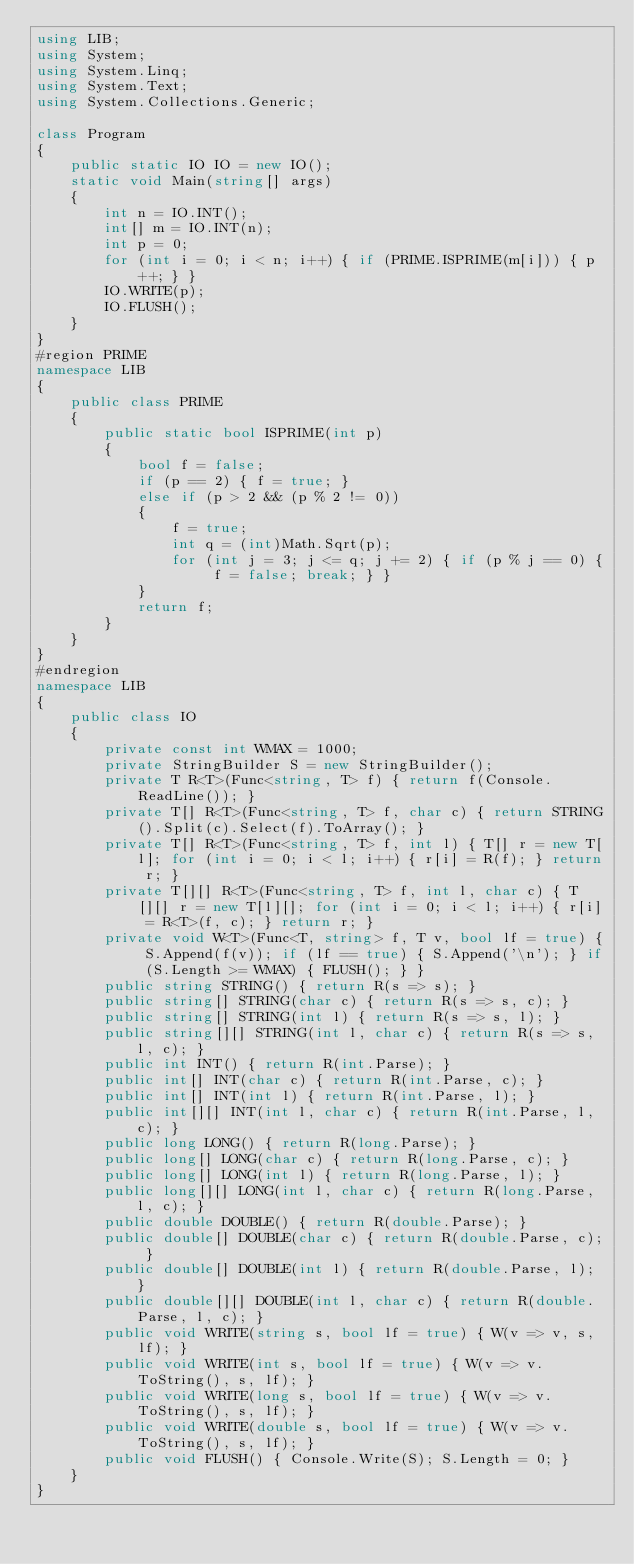<code> <loc_0><loc_0><loc_500><loc_500><_C#_>using LIB;
using System;
using System.Linq;
using System.Text;
using System.Collections.Generic;

class Program
{
    public static IO IO = new IO();
    static void Main(string[] args)
    {
        int n = IO.INT();
        int[] m = IO.INT(n);
        int p = 0;
        for (int i = 0; i < n; i++) { if (PRIME.ISPRIME(m[i])) { p++; } }
        IO.WRITE(p);
        IO.FLUSH();
    }
}
#region PRIME
namespace LIB
{
    public class PRIME
    {
        public static bool ISPRIME(int p)
        {
            bool f = false;
            if (p == 2) { f = true; }
            else if (p > 2 && (p % 2 != 0))
            {
                f = true;
                int q = (int)Math.Sqrt(p);
                for (int j = 3; j <= q; j += 2) { if (p % j == 0) { f = false; break; } }
            }
            return f;
        }
    }
}
#endregion
namespace LIB
{
    public class IO
    {
        private const int WMAX = 1000;
        private StringBuilder S = new StringBuilder();
        private T R<T>(Func<string, T> f) { return f(Console.ReadLine()); }
        private T[] R<T>(Func<string, T> f, char c) { return STRING().Split(c).Select(f).ToArray(); }
        private T[] R<T>(Func<string, T> f, int l) { T[] r = new T[l]; for (int i = 0; i < l; i++) { r[i] = R(f); } return r; }
        private T[][] R<T>(Func<string, T> f, int l, char c) { T[][] r = new T[l][]; for (int i = 0; i < l; i++) { r[i] = R<T>(f, c); } return r; }
        private void W<T>(Func<T, string> f, T v, bool lf = true) { S.Append(f(v)); if (lf == true) { S.Append('\n'); } if (S.Length >= WMAX) { FLUSH(); } }
        public string STRING() { return R(s => s); }
        public string[] STRING(char c) { return R(s => s, c); }
        public string[] STRING(int l) { return R(s => s, l); }
        public string[][] STRING(int l, char c) { return R(s => s, l, c); }
        public int INT() { return R(int.Parse); }
        public int[] INT(char c) { return R(int.Parse, c); }
        public int[] INT(int l) { return R(int.Parse, l); }
        public int[][] INT(int l, char c) { return R(int.Parse, l, c); }
        public long LONG() { return R(long.Parse); }
        public long[] LONG(char c) { return R(long.Parse, c); }
        public long[] LONG(int l) { return R(long.Parse, l); }
        public long[][] LONG(int l, char c) { return R(long.Parse, l, c); }
        public double DOUBLE() { return R(double.Parse); }
        public double[] DOUBLE(char c) { return R(double.Parse, c); }
        public double[] DOUBLE(int l) { return R(double.Parse, l); }
        public double[][] DOUBLE(int l, char c) { return R(double.Parse, l, c); }
        public void WRITE(string s, bool lf = true) { W(v => v, s, lf); }
        public void WRITE(int s, bool lf = true) { W(v => v.ToString(), s, lf); }
        public void WRITE(long s, bool lf = true) { W(v => v.ToString(), s, lf); }
        public void WRITE(double s, bool lf = true) { W(v => v.ToString(), s, lf); }
        public void FLUSH() { Console.Write(S); S.Length = 0; }
    }
}</code> 